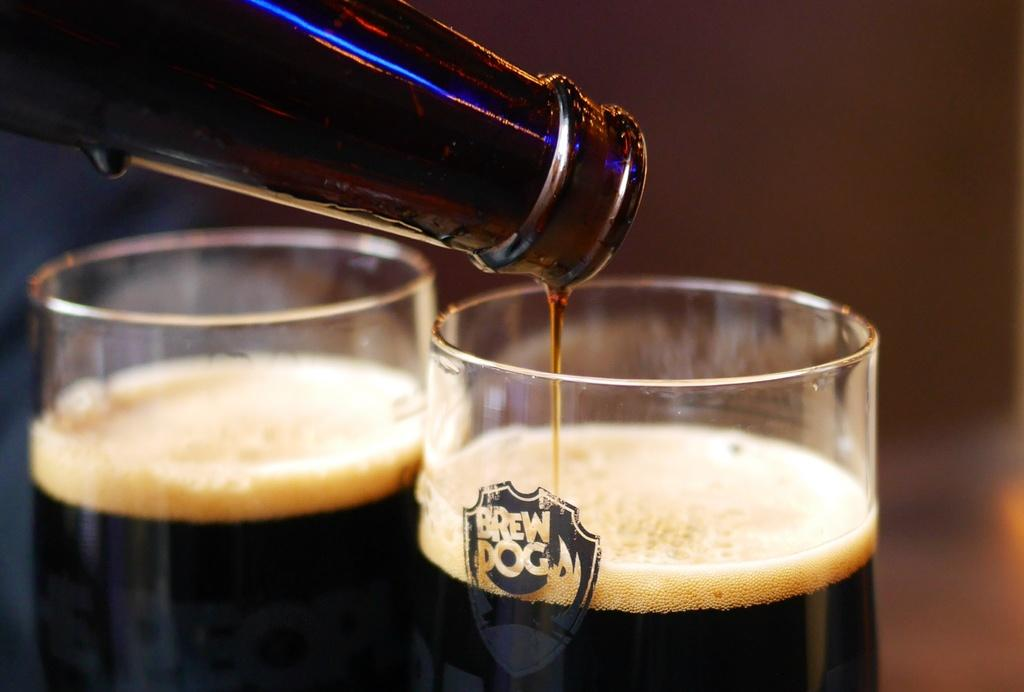<image>
Summarize the visual content of the image. Two glasses one that says Brew dog sitting on a table. 